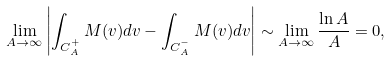Convert formula to latex. <formula><loc_0><loc_0><loc_500><loc_500>\lim _ { A \to \infty } \left | \int _ { C _ { A } ^ { + } } M ( v ) d v - \int _ { C _ { A } ^ { - } } M ( v ) d v \right | \sim \lim _ { A \to \infty } \frac { \ln A } { A } = 0 ,</formula> 